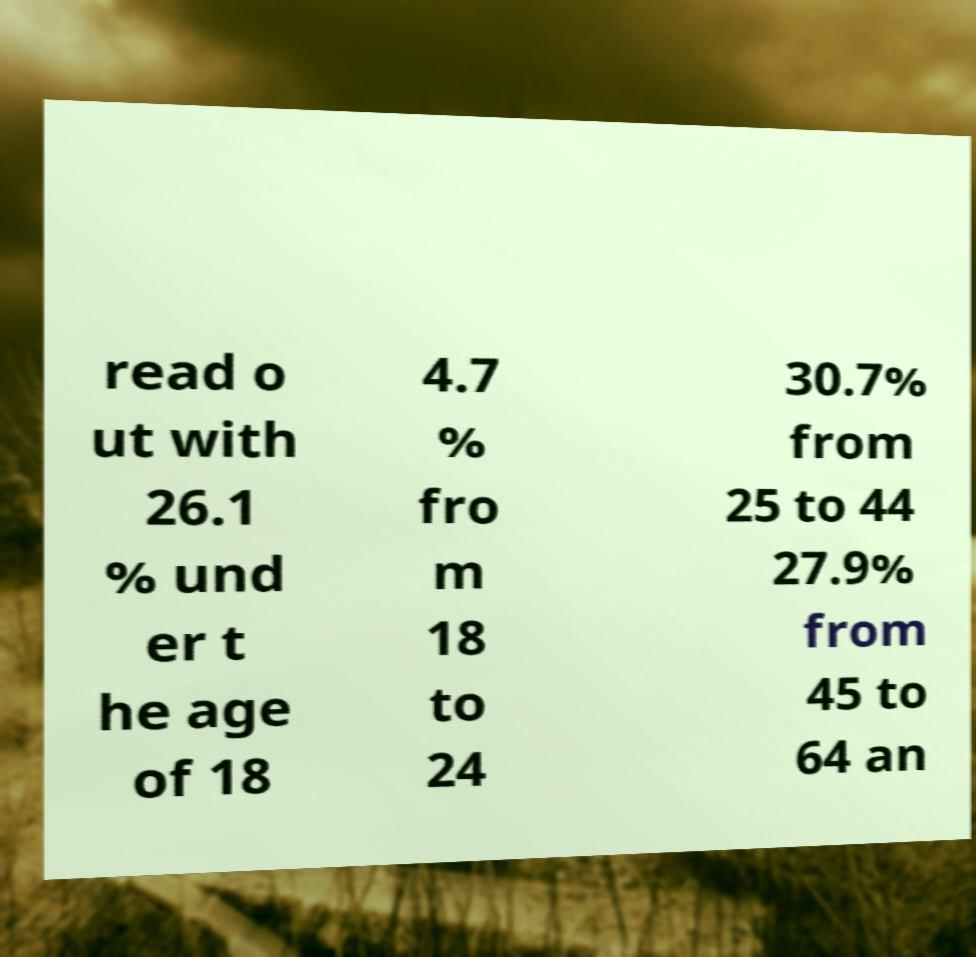What messages or text are displayed in this image? I need them in a readable, typed format. read o ut with 26.1 % und er t he age of 18 4.7 % fro m 18 to 24 30.7% from 25 to 44 27.9% from 45 to 64 an 